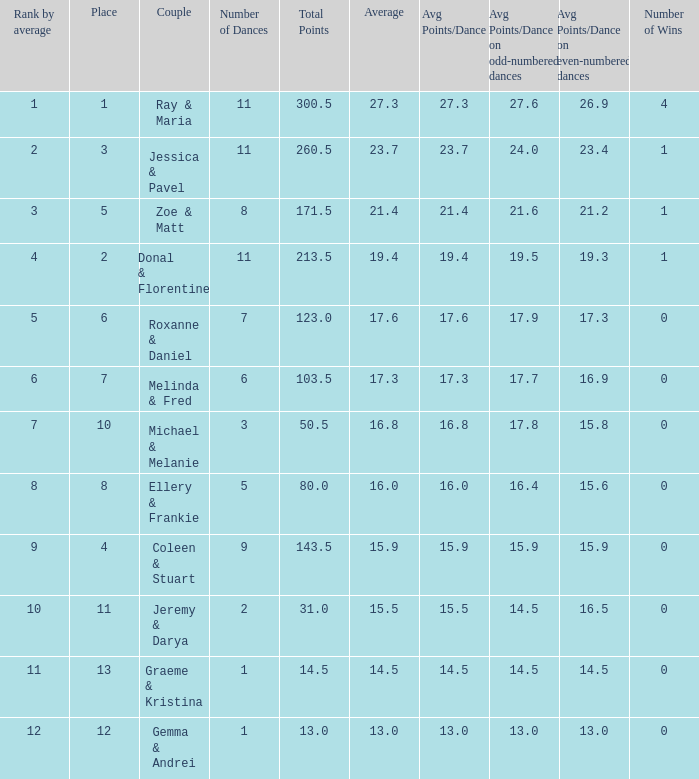If your rank by average is 9, what is the name of the couple? Coleen & Stuart. 